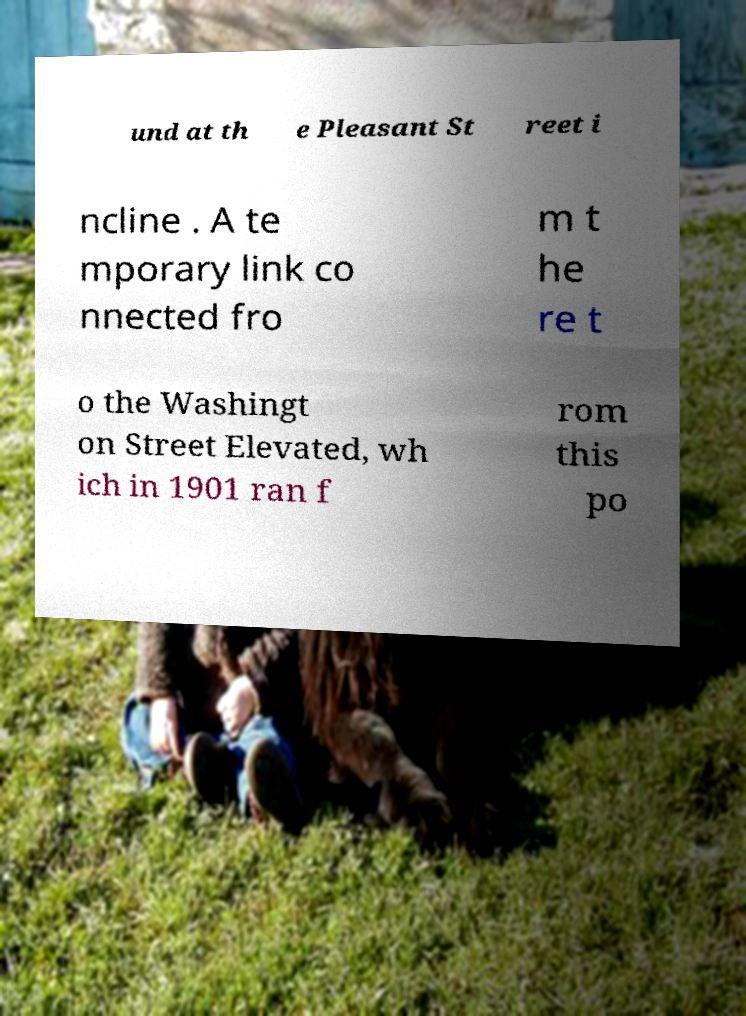Could you extract and type out the text from this image? und at th e Pleasant St reet i ncline . A te mporary link co nnected fro m t he re t o the Washingt on Street Elevated, wh ich in 1901 ran f rom this po 